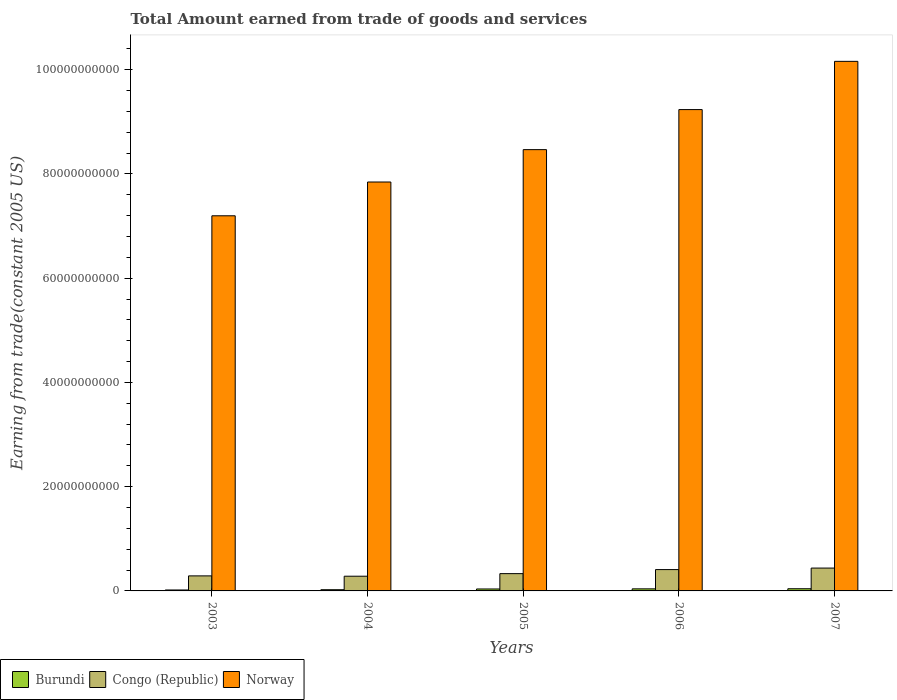How many different coloured bars are there?
Keep it short and to the point. 3. Are the number of bars per tick equal to the number of legend labels?
Give a very brief answer. Yes. Are the number of bars on each tick of the X-axis equal?
Make the answer very short. Yes. How many bars are there on the 4th tick from the right?
Your answer should be compact. 3. What is the label of the 2nd group of bars from the left?
Keep it short and to the point. 2004. What is the total amount earned by trading goods and services in Norway in 2004?
Give a very brief answer. 7.85e+1. Across all years, what is the maximum total amount earned by trading goods and services in Congo (Republic)?
Your response must be concise. 4.39e+09. Across all years, what is the minimum total amount earned by trading goods and services in Burundi?
Keep it short and to the point. 1.82e+08. In which year was the total amount earned by trading goods and services in Burundi minimum?
Offer a terse response. 2003. What is the total total amount earned by trading goods and services in Burundi in the graph?
Keep it short and to the point. 1.60e+09. What is the difference between the total amount earned by trading goods and services in Norway in 2004 and that in 2006?
Your answer should be compact. -1.39e+1. What is the difference between the total amount earned by trading goods and services in Congo (Republic) in 2007 and the total amount earned by trading goods and services in Norway in 2005?
Your answer should be very brief. -8.03e+1. What is the average total amount earned by trading goods and services in Burundi per year?
Give a very brief answer. 3.21e+08. In the year 2005, what is the difference between the total amount earned by trading goods and services in Burundi and total amount earned by trading goods and services in Congo (Republic)?
Keep it short and to the point. -2.94e+09. In how many years, is the total amount earned by trading goods and services in Congo (Republic) greater than 8000000000 US$?
Your response must be concise. 0. What is the ratio of the total amount earned by trading goods and services in Congo (Republic) in 2003 to that in 2006?
Keep it short and to the point. 0.7. Is the total amount earned by trading goods and services in Congo (Republic) in 2003 less than that in 2007?
Give a very brief answer. Yes. Is the difference between the total amount earned by trading goods and services in Burundi in 2005 and 2007 greater than the difference between the total amount earned by trading goods and services in Congo (Republic) in 2005 and 2007?
Keep it short and to the point. Yes. What is the difference between the highest and the second highest total amount earned by trading goods and services in Congo (Republic)?
Offer a very short reply. 2.92e+08. What is the difference between the highest and the lowest total amount earned by trading goods and services in Norway?
Provide a short and direct response. 2.96e+1. Is the sum of the total amount earned by trading goods and services in Burundi in 2005 and 2006 greater than the maximum total amount earned by trading goods and services in Congo (Republic) across all years?
Provide a succinct answer. No. What does the 3rd bar from the left in 2007 represents?
Provide a short and direct response. Norway. What does the 3rd bar from the right in 2007 represents?
Make the answer very short. Burundi. How many bars are there?
Provide a succinct answer. 15. How many years are there in the graph?
Give a very brief answer. 5. What is the difference between two consecutive major ticks on the Y-axis?
Ensure brevity in your answer.  2.00e+1. Are the values on the major ticks of Y-axis written in scientific E-notation?
Provide a short and direct response. No. Does the graph contain grids?
Provide a succinct answer. No. How are the legend labels stacked?
Provide a short and direct response. Horizontal. What is the title of the graph?
Make the answer very short. Total Amount earned from trade of goods and services. What is the label or title of the X-axis?
Offer a terse response. Years. What is the label or title of the Y-axis?
Keep it short and to the point. Earning from trade(constant 2005 US). What is the Earning from trade(constant 2005 US) in Burundi in 2003?
Provide a succinct answer. 1.82e+08. What is the Earning from trade(constant 2005 US) of Congo (Republic) in 2003?
Offer a very short reply. 2.88e+09. What is the Earning from trade(constant 2005 US) of Norway in 2003?
Your response must be concise. 7.20e+1. What is the Earning from trade(constant 2005 US) of Burundi in 2004?
Offer a very short reply. 2.31e+08. What is the Earning from trade(constant 2005 US) of Congo (Republic) in 2004?
Your response must be concise. 2.82e+09. What is the Earning from trade(constant 2005 US) of Norway in 2004?
Provide a succinct answer. 7.85e+1. What is the Earning from trade(constant 2005 US) in Burundi in 2005?
Your answer should be very brief. 3.74e+08. What is the Earning from trade(constant 2005 US) in Congo (Republic) in 2005?
Your response must be concise. 3.32e+09. What is the Earning from trade(constant 2005 US) of Norway in 2005?
Your answer should be compact. 8.47e+1. What is the Earning from trade(constant 2005 US) of Burundi in 2006?
Offer a very short reply. 3.99e+08. What is the Earning from trade(constant 2005 US) of Congo (Republic) in 2006?
Provide a short and direct response. 4.09e+09. What is the Earning from trade(constant 2005 US) in Norway in 2006?
Provide a short and direct response. 9.24e+1. What is the Earning from trade(constant 2005 US) of Burundi in 2007?
Your response must be concise. 4.18e+08. What is the Earning from trade(constant 2005 US) of Congo (Republic) in 2007?
Offer a terse response. 4.39e+09. What is the Earning from trade(constant 2005 US) of Norway in 2007?
Keep it short and to the point. 1.02e+11. Across all years, what is the maximum Earning from trade(constant 2005 US) of Burundi?
Give a very brief answer. 4.18e+08. Across all years, what is the maximum Earning from trade(constant 2005 US) of Congo (Republic)?
Offer a very short reply. 4.39e+09. Across all years, what is the maximum Earning from trade(constant 2005 US) in Norway?
Offer a terse response. 1.02e+11. Across all years, what is the minimum Earning from trade(constant 2005 US) of Burundi?
Offer a very short reply. 1.82e+08. Across all years, what is the minimum Earning from trade(constant 2005 US) in Congo (Republic)?
Give a very brief answer. 2.82e+09. Across all years, what is the minimum Earning from trade(constant 2005 US) of Norway?
Provide a short and direct response. 7.20e+1. What is the total Earning from trade(constant 2005 US) in Burundi in the graph?
Keep it short and to the point. 1.60e+09. What is the total Earning from trade(constant 2005 US) in Congo (Republic) in the graph?
Ensure brevity in your answer.  1.75e+1. What is the total Earning from trade(constant 2005 US) in Norway in the graph?
Offer a terse response. 4.29e+11. What is the difference between the Earning from trade(constant 2005 US) in Burundi in 2003 and that in 2004?
Your answer should be very brief. -4.93e+07. What is the difference between the Earning from trade(constant 2005 US) in Congo (Republic) in 2003 and that in 2004?
Your response must be concise. 6.26e+07. What is the difference between the Earning from trade(constant 2005 US) in Norway in 2003 and that in 2004?
Provide a succinct answer. -6.48e+09. What is the difference between the Earning from trade(constant 2005 US) in Burundi in 2003 and that in 2005?
Provide a succinct answer. -1.92e+08. What is the difference between the Earning from trade(constant 2005 US) of Congo (Republic) in 2003 and that in 2005?
Keep it short and to the point. -4.33e+08. What is the difference between the Earning from trade(constant 2005 US) in Norway in 2003 and that in 2005?
Keep it short and to the point. -1.27e+1. What is the difference between the Earning from trade(constant 2005 US) of Burundi in 2003 and that in 2006?
Your answer should be compact. -2.17e+08. What is the difference between the Earning from trade(constant 2005 US) in Congo (Republic) in 2003 and that in 2006?
Offer a terse response. -1.21e+09. What is the difference between the Earning from trade(constant 2005 US) in Norway in 2003 and that in 2006?
Provide a succinct answer. -2.04e+1. What is the difference between the Earning from trade(constant 2005 US) of Burundi in 2003 and that in 2007?
Make the answer very short. -2.37e+08. What is the difference between the Earning from trade(constant 2005 US) of Congo (Republic) in 2003 and that in 2007?
Ensure brevity in your answer.  -1.50e+09. What is the difference between the Earning from trade(constant 2005 US) in Norway in 2003 and that in 2007?
Your response must be concise. -2.96e+1. What is the difference between the Earning from trade(constant 2005 US) in Burundi in 2004 and that in 2005?
Offer a very short reply. -1.43e+08. What is the difference between the Earning from trade(constant 2005 US) of Congo (Republic) in 2004 and that in 2005?
Your answer should be very brief. -4.96e+08. What is the difference between the Earning from trade(constant 2005 US) of Norway in 2004 and that in 2005?
Offer a very short reply. -6.21e+09. What is the difference between the Earning from trade(constant 2005 US) of Burundi in 2004 and that in 2006?
Make the answer very short. -1.67e+08. What is the difference between the Earning from trade(constant 2005 US) in Congo (Republic) in 2004 and that in 2006?
Keep it short and to the point. -1.27e+09. What is the difference between the Earning from trade(constant 2005 US) of Norway in 2004 and that in 2006?
Offer a very short reply. -1.39e+1. What is the difference between the Earning from trade(constant 2005 US) in Burundi in 2004 and that in 2007?
Offer a very short reply. -1.87e+08. What is the difference between the Earning from trade(constant 2005 US) of Congo (Republic) in 2004 and that in 2007?
Your response must be concise. -1.56e+09. What is the difference between the Earning from trade(constant 2005 US) of Norway in 2004 and that in 2007?
Your answer should be compact. -2.31e+1. What is the difference between the Earning from trade(constant 2005 US) in Burundi in 2005 and that in 2006?
Give a very brief answer. -2.49e+07. What is the difference between the Earning from trade(constant 2005 US) of Congo (Republic) in 2005 and that in 2006?
Provide a succinct answer. -7.75e+08. What is the difference between the Earning from trade(constant 2005 US) in Norway in 2005 and that in 2006?
Keep it short and to the point. -7.68e+09. What is the difference between the Earning from trade(constant 2005 US) in Burundi in 2005 and that in 2007?
Keep it short and to the point. -4.48e+07. What is the difference between the Earning from trade(constant 2005 US) of Congo (Republic) in 2005 and that in 2007?
Provide a short and direct response. -1.07e+09. What is the difference between the Earning from trade(constant 2005 US) in Norway in 2005 and that in 2007?
Give a very brief answer. -1.69e+1. What is the difference between the Earning from trade(constant 2005 US) in Burundi in 2006 and that in 2007?
Your response must be concise. -1.99e+07. What is the difference between the Earning from trade(constant 2005 US) in Congo (Republic) in 2006 and that in 2007?
Provide a succinct answer. -2.92e+08. What is the difference between the Earning from trade(constant 2005 US) of Norway in 2006 and that in 2007?
Make the answer very short. -9.25e+09. What is the difference between the Earning from trade(constant 2005 US) in Burundi in 2003 and the Earning from trade(constant 2005 US) in Congo (Republic) in 2004?
Ensure brevity in your answer.  -2.64e+09. What is the difference between the Earning from trade(constant 2005 US) of Burundi in 2003 and the Earning from trade(constant 2005 US) of Norway in 2004?
Keep it short and to the point. -7.83e+1. What is the difference between the Earning from trade(constant 2005 US) of Congo (Republic) in 2003 and the Earning from trade(constant 2005 US) of Norway in 2004?
Offer a terse response. -7.56e+1. What is the difference between the Earning from trade(constant 2005 US) of Burundi in 2003 and the Earning from trade(constant 2005 US) of Congo (Republic) in 2005?
Provide a succinct answer. -3.14e+09. What is the difference between the Earning from trade(constant 2005 US) in Burundi in 2003 and the Earning from trade(constant 2005 US) in Norway in 2005?
Provide a short and direct response. -8.45e+1. What is the difference between the Earning from trade(constant 2005 US) in Congo (Republic) in 2003 and the Earning from trade(constant 2005 US) in Norway in 2005?
Keep it short and to the point. -8.18e+1. What is the difference between the Earning from trade(constant 2005 US) in Burundi in 2003 and the Earning from trade(constant 2005 US) in Congo (Republic) in 2006?
Your answer should be compact. -3.91e+09. What is the difference between the Earning from trade(constant 2005 US) in Burundi in 2003 and the Earning from trade(constant 2005 US) in Norway in 2006?
Give a very brief answer. -9.22e+1. What is the difference between the Earning from trade(constant 2005 US) of Congo (Republic) in 2003 and the Earning from trade(constant 2005 US) of Norway in 2006?
Provide a short and direct response. -8.95e+1. What is the difference between the Earning from trade(constant 2005 US) in Burundi in 2003 and the Earning from trade(constant 2005 US) in Congo (Republic) in 2007?
Ensure brevity in your answer.  -4.20e+09. What is the difference between the Earning from trade(constant 2005 US) of Burundi in 2003 and the Earning from trade(constant 2005 US) of Norway in 2007?
Your response must be concise. -1.01e+11. What is the difference between the Earning from trade(constant 2005 US) in Congo (Republic) in 2003 and the Earning from trade(constant 2005 US) in Norway in 2007?
Make the answer very short. -9.87e+1. What is the difference between the Earning from trade(constant 2005 US) in Burundi in 2004 and the Earning from trade(constant 2005 US) in Congo (Republic) in 2005?
Provide a short and direct response. -3.09e+09. What is the difference between the Earning from trade(constant 2005 US) in Burundi in 2004 and the Earning from trade(constant 2005 US) in Norway in 2005?
Your answer should be very brief. -8.44e+1. What is the difference between the Earning from trade(constant 2005 US) in Congo (Republic) in 2004 and the Earning from trade(constant 2005 US) in Norway in 2005?
Make the answer very short. -8.18e+1. What is the difference between the Earning from trade(constant 2005 US) in Burundi in 2004 and the Earning from trade(constant 2005 US) in Congo (Republic) in 2006?
Provide a succinct answer. -3.86e+09. What is the difference between the Earning from trade(constant 2005 US) in Burundi in 2004 and the Earning from trade(constant 2005 US) in Norway in 2006?
Give a very brief answer. -9.21e+1. What is the difference between the Earning from trade(constant 2005 US) in Congo (Republic) in 2004 and the Earning from trade(constant 2005 US) in Norway in 2006?
Your answer should be very brief. -8.95e+1. What is the difference between the Earning from trade(constant 2005 US) of Burundi in 2004 and the Earning from trade(constant 2005 US) of Congo (Republic) in 2007?
Your answer should be very brief. -4.15e+09. What is the difference between the Earning from trade(constant 2005 US) of Burundi in 2004 and the Earning from trade(constant 2005 US) of Norway in 2007?
Make the answer very short. -1.01e+11. What is the difference between the Earning from trade(constant 2005 US) in Congo (Republic) in 2004 and the Earning from trade(constant 2005 US) in Norway in 2007?
Provide a short and direct response. -9.88e+1. What is the difference between the Earning from trade(constant 2005 US) of Burundi in 2005 and the Earning from trade(constant 2005 US) of Congo (Republic) in 2006?
Provide a short and direct response. -3.72e+09. What is the difference between the Earning from trade(constant 2005 US) in Burundi in 2005 and the Earning from trade(constant 2005 US) in Norway in 2006?
Keep it short and to the point. -9.20e+1. What is the difference between the Earning from trade(constant 2005 US) in Congo (Republic) in 2005 and the Earning from trade(constant 2005 US) in Norway in 2006?
Keep it short and to the point. -8.90e+1. What is the difference between the Earning from trade(constant 2005 US) in Burundi in 2005 and the Earning from trade(constant 2005 US) in Congo (Republic) in 2007?
Make the answer very short. -4.01e+09. What is the difference between the Earning from trade(constant 2005 US) in Burundi in 2005 and the Earning from trade(constant 2005 US) in Norway in 2007?
Provide a short and direct response. -1.01e+11. What is the difference between the Earning from trade(constant 2005 US) in Congo (Republic) in 2005 and the Earning from trade(constant 2005 US) in Norway in 2007?
Make the answer very short. -9.83e+1. What is the difference between the Earning from trade(constant 2005 US) in Burundi in 2006 and the Earning from trade(constant 2005 US) in Congo (Republic) in 2007?
Offer a terse response. -3.99e+09. What is the difference between the Earning from trade(constant 2005 US) in Burundi in 2006 and the Earning from trade(constant 2005 US) in Norway in 2007?
Your answer should be very brief. -1.01e+11. What is the difference between the Earning from trade(constant 2005 US) in Congo (Republic) in 2006 and the Earning from trade(constant 2005 US) in Norway in 2007?
Give a very brief answer. -9.75e+1. What is the average Earning from trade(constant 2005 US) of Burundi per year?
Provide a succinct answer. 3.21e+08. What is the average Earning from trade(constant 2005 US) in Congo (Republic) per year?
Make the answer very short. 3.50e+09. What is the average Earning from trade(constant 2005 US) in Norway per year?
Make the answer very short. 8.58e+1. In the year 2003, what is the difference between the Earning from trade(constant 2005 US) in Burundi and Earning from trade(constant 2005 US) in Congo (Republic)?
Keep it short and to the point. -2.70e+09. In the year 2003, what is the difference between the Earning from trade(constant 2005 US) of Burundi and Earning from trade(constant 2005 US) of Norway?
Offer a terse response. -7.18e+1. In the year 2003, what is the difference between the Earning from trade(constant 2005 US) of Congo (Republic) and Earning from trade(constant 2005 US) of Norway?
Provide a succinct answer. -6.91e+1. In the year 2004, what is the difference between the Earning from trade(constant 2005 US) of Burundi and Earning from trade(constant 2005 US) of Congo (Republic)?
Keep it short and to the point. -2.59e+09. In the year 2004, what is the difference between the Earning from trade(constant 2005 US) of Burundi and Earning from trade(constant 2005 US) of Norway?
Your answer should be compact. -7.82e+1. In the year 2004, what is the difference between the Earning from trade(constant 2005 US) of Congo (Republic) and Earning from trade(constant 2005 US) of Norway?
Provide a short and direct response. -7.56e+1. In the year 2005, what is the difference between the Earning from trade(constant 2005 US) in Burundi and Earning from trade(constant 2005 US) in Congo (Republic)?
Your response must be concise. -2.94e+09. In the year 2005, what is the difference between the Earning from trade(constant 2005 US) of Burundi and Earning from trade(constant 2005 US) of Norway?
Make the answer very short. -8.43e+1. In the year 2005, what is the difference between the Earning from trade(constant 2005 US) in Congo (Republic) and Earning from trade(constant 2005 US) in Norway?
Make the answer very short. -8.14e+1. In the year 2006, what is the difference between the Earning from trade(constant 2005 US) of Burundi and Earning from trade(constant 2005 US) of Congo (Republic)?
Your answer should be very brief. -3.69e+09. In the year 2006, what is the difference between the Earning from trade(constant 2005 US) of Burundi and Earning from trade(constant 2005 US) of Norway?
Make the answer very short. -9.20e+1. In the year 2006, what is the difference between the Earning from trade(constant 2005 US) in Congo (Republic) and Earning from trade(constant 2005 US) in Norway?
Make the answer very short. -8.83e+1. In the year 2007, what is the difference between the Earning from trade(constant 2005 US) in Burundi and Earning from trade(constant 2005 US) in Congo (Republic)?
Ensure brevity in your answer.  -3.97e+09. In the year 2007, what is the difference between the Earning from trade(constant 2005 US) of Burundi and Earning from trade(constant 2005 US) of Norway?
Offer a terse response. -1.01e+11. In the year 2007, what is the difference between the Earning from trade(constant 2005 US) in Congo (Republic) and Earning from trade(constant 2005 US) in Norway?
Your answer should be very brief. -9.72e+1. What is the ratio of the Earning from trade(constant 2005 US) in Burundi in 2003 to that in 2004?
Provide a succinct answer. 0.79. What is the ratio of the Earning from trade(constant 2005 US) of Congo (Republic) in 2003 to that in 2004?
Your answer should be very brief. 1.02. What is the ratio of the Earning from trade(constant 2005 US) of Norway in 2003 to that in 2004?
Provide a succinct answer. 0.92. What is the ratio of the Earning from trade(constant 2005 US) of Burundi in 2003 to that in 2005?
Keep it short and to the point. 0.49. What is the ratio of the Earning from trade(constant 2005 US) of Congo (Republic) in 2003 to that in 2005?
Your answer should be very brief. 0.87. What is the ratio of the Earning from trade(constant 2005 US) in Norway in 2003 to that in 2005?
Provide a succinct answer. 0.85. What is the ratio of the Earning from trade(constant 2005 US) of Burundi in 2003 to that in 2006?
Provide a succinct answer. 0.46. What is the ratio of the Earning from trade(constant 2005 US) in Congo (Republic) in 2003 to that in 2006?
Keep it short and to the point. 0.7. What is the ratio of the Earning from trade(constant 2005 US) in Norway in 2003 to that in 2006?
Give a very brief answer. 0.78. What is the ratio of the Earning from trade(constant 2005 US) of Burundi in 2003 to that in 2007?
Your answer should be compact. 0.43. What is the ratio of the Earning from trade(constant 2005 US) in Congo (Republic) in 2003 to that in 2007?
Offer a terse response. 0.66. What is the ratio of the Earning from trade(constant 2005 US) of Norway in 2003 to that in 2007?
Provide a succinct answer. 0.71. What is the ratio of the Earning from trade(constant 2005 US) of Burundi in 2004 to that in 2005?
Your response must be concise. 0.62. What is the ratio of the Earning from trade(constant 2005 US) of Congo (Republic) in 2004 to that in 2005?
Your response must be concise. 0.85. What is the ratio of the Earning from trade(constant 2005 US) of Norway in 2004 to that in 2005?
Your response must be concise. 0.93. What is the ratio of the Earning from trade(constant 2005 US) of Burundi in 2004 to that in 2006?
Provide a short and direct response. 0.58. What is the ratio of the Earning from trade(constant 2005 US) of Congo (Republic) in 2004 to that in 2006?
Offer a terse response. 0.69. What is the ratio of the Earning from trade(constant 2005 US) in Norway in 2004 to that in 2006?
Offer a very short reply. 0.85. What is the ratio of the Earning from trade(constant 2005 US) of Burundi in 2004 to that in 2007?
Make the answer very short. 0.55. What is the ratio of the Earning from trade(constant 2005 US) of Congo (Republic) in 2004 to that in 2007?
Offer a very short reply. 0.64. What is the ratio of the Earning from trade(constant 2005 US) of Norway in 2004 to that in 2007?
Offer a very short reply. 0.77. What is the ratio of the Earning from trade(constant 2005 US) in Burundi in 2005 to that in 2006?
Your answer should be compact. 0.94. What is the ratio of the Earning from trade(constant 2005 US) in Congo (Republic) in 2005 to that in 2006?
Provide a succinct answer. 0.81. What is the ratio of the Earning from trade(constant 2005 US) in Norway in 2005 to that in 2006?
Provide a succinct answer. 0.92. What is the ratio of the Earning from trade(constant 2005 US) in Burundi in 2005 to that in 2007?
Offer a terse response. 0.89. What is the ratio of the Earning from trade(constant 2005 US) of Congo (Republic) in 2005 to that in 2007?
Give a very brief answer. 0.76. What is the ratio of the Earning from trade(constant 2005 US) of Norway in 2005 to that in 2007?
Offer a very short reply. 0.83. What is the ratio of the Earning from trade(constant 2005 US) of Congo (Republic) in 2006 to that in 2007?
Your answer should be very brief. 0.93. What is the ratio of the Earning from trade(constant 2005 US) of Norway in 2006 to that in 2007?
Provide a short and direct response. 0.91. What is the difference between the highest and the second highest Earning from trade(constant 2005 US) of Burundi?
Offer a very short reply. 1.99e+07. What is the difference between the highest and the second highest Earning from trade(constant 2005 US) in Congo (Republic)?
Provide a succinct answer. 2.92e+08. What is the difference between the highest and the second highest Earning from trade(constant 2005 US) of Norway?
Offer a terse response. 9.25e+09. What is the difference between the highest and the lowest Earning from trade(constant 2005 US) in Burundi?
Make the answer very short. 2.37e+08. What is the difference between the highest and the lowest Earning from trade(constant 2005 US) of Congo (Republic)?
Offer a very short reply. 1.56e+09. What is the difference between the highest and the lowest Earning from trade(constant 2005 US) in Norway?
Provide a short and direct response. 2.96e+1. 